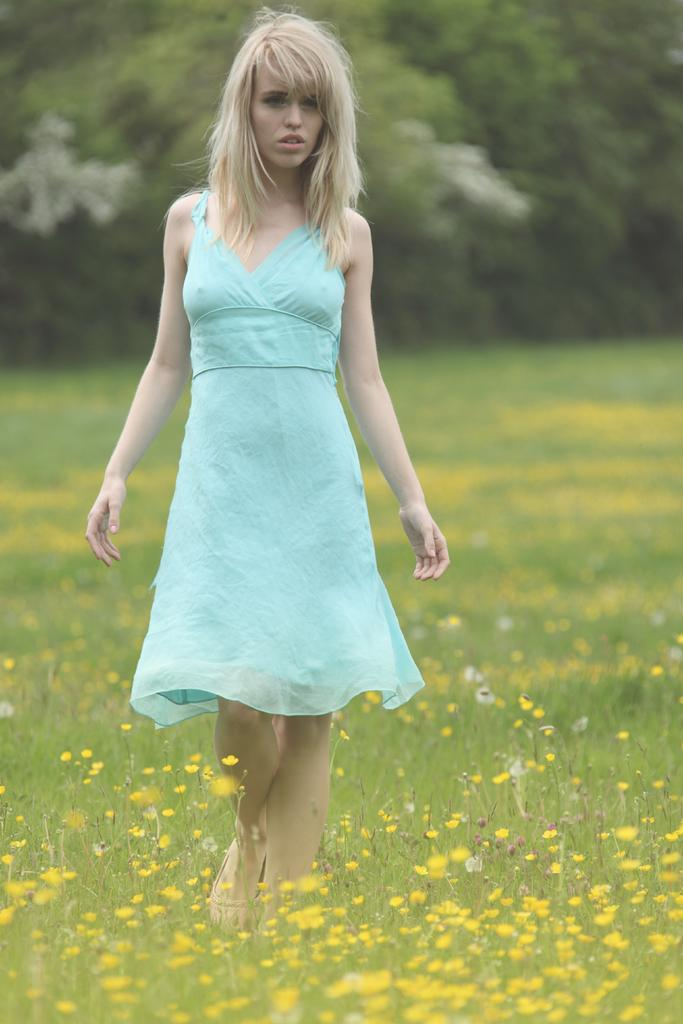Who is present in the image? There is a woman in the image. What type of vegetation can be seen in the image? There is grass and flowers in the image. What can be seen in the background of the image? There are trees in the background of the image. How many sisters does the woman have in the image? There is no information about the woman's sisters in the image. What is the woman doing with her arm in the image? There is no information about the woman's arm or any actions she might be performing in the image. 